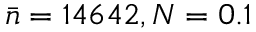<formula> <loc_0><loc_0><loc_500><loc_500>\bar { n } = 1 4 6 4 2 , N = 0 . 1</formula> 